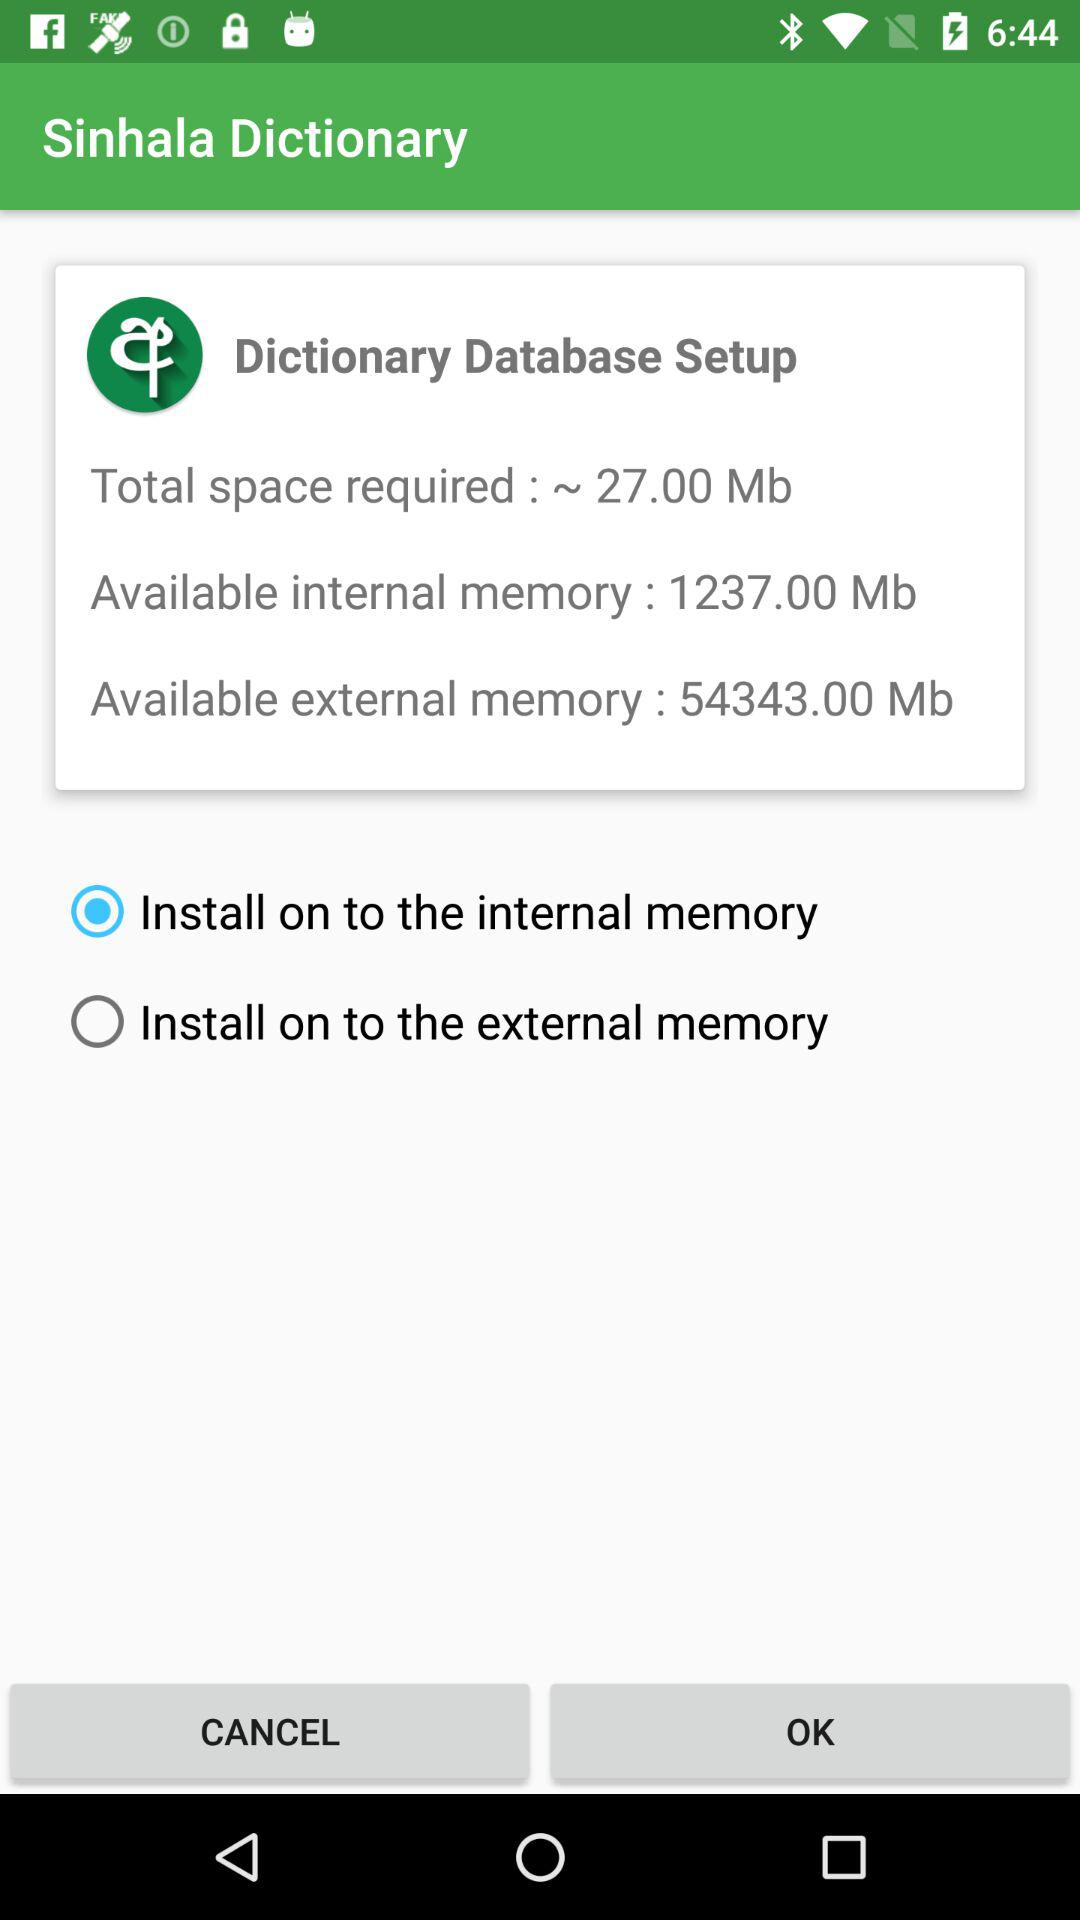What is the status of the external memory? The status is off. 